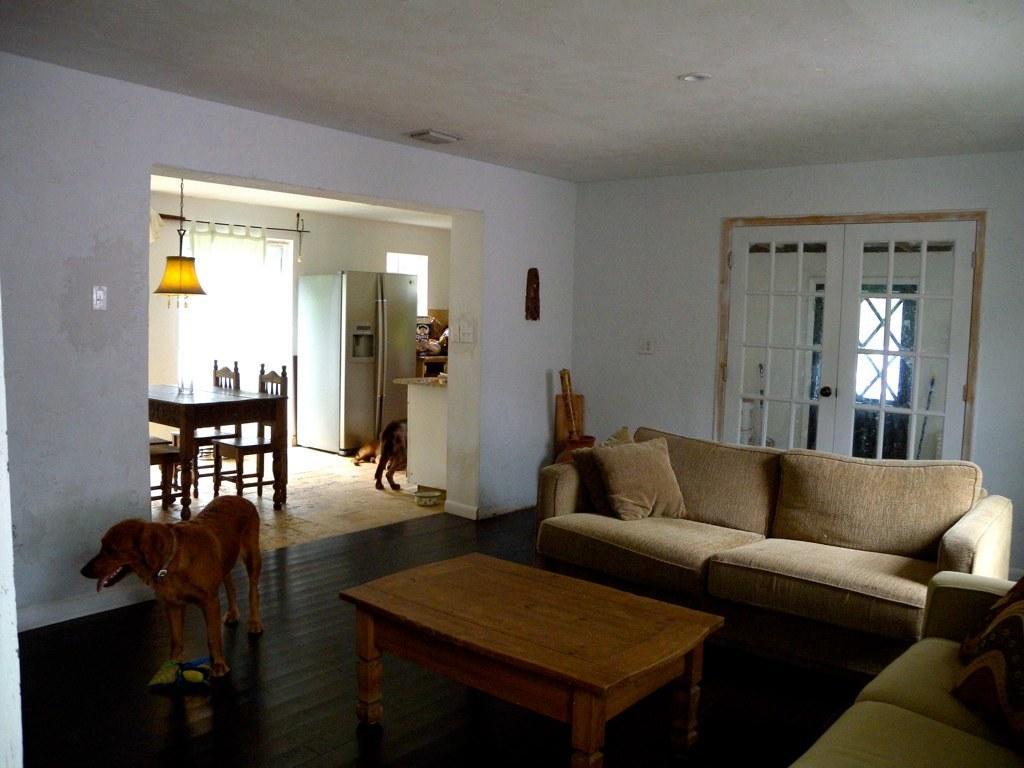In one or two sentences, can you explain what this image depicts? In the image the left there is a dog watching something,beside the dog there is a table. And back of table there is a sofa and wall,in center there is another dog beside the dog there is dining table back of that there is a fridge. 